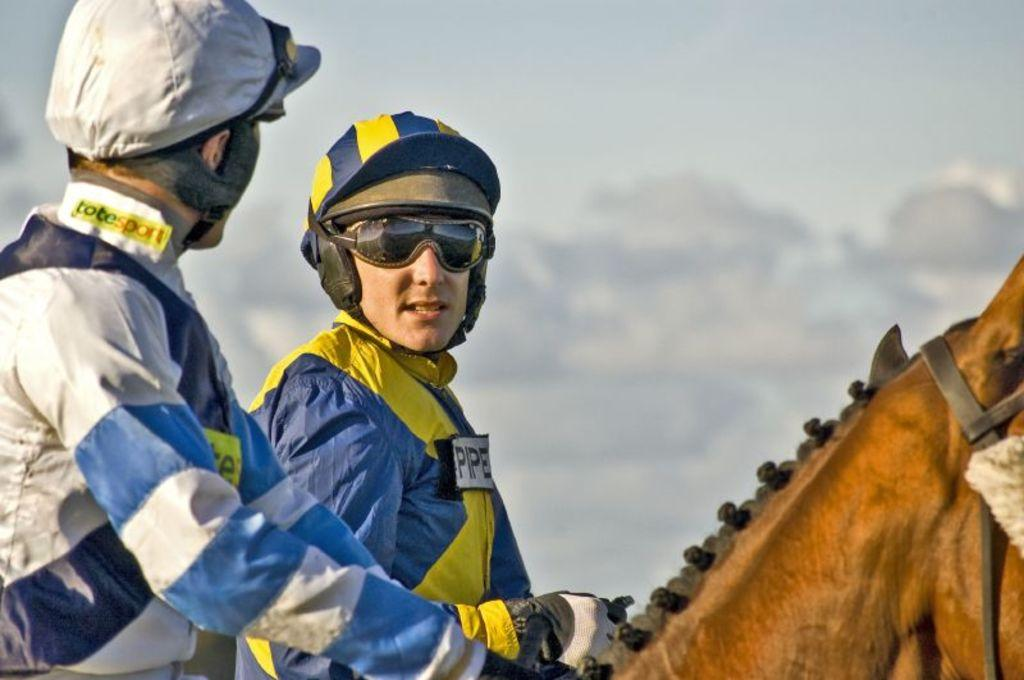How many people are in the image? There are two persons in the image. What else can be seen in the image besides the people? There is an animal in the image. Can you describe the background of the image? The background of the image is blurred. What type of manager is overseeing the animal in the image? There is no manager present in the image, and the animal is not being overseen by anyone. 